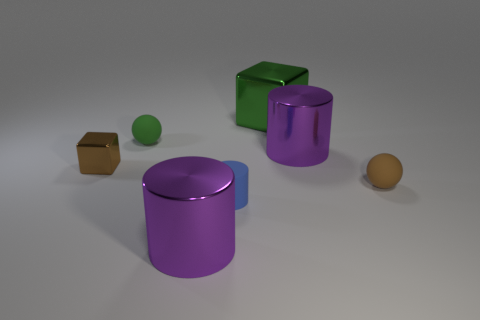Add 2 small yellow metal cylinders. How many objects exist? 9 Subtract all blocks. How many objects are left? 5 Subtract all small blue cylinders. Subtract all small brown metallic things. How many objects are left? 5 Add 5 green cubes. How many green cubes are left? 6 Add 1 big metallic cubes. How many big metallic cubes exist? 2 Subtract 0 yellow cylinders. How many objects are left? 7 